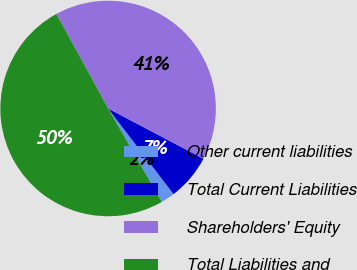<chart> <loc_0><loc_0><loc_500><loc_500><pie_chart><fcel>Other current liabilities<fcel>Total Current Liabilities<fcel>Shareholders' Equity<fcel>Total Liabilities and<nl><fcel>2.08%<fcel>6.91%<fcel>40.67%<fcel>50.35%<nl></chart> 